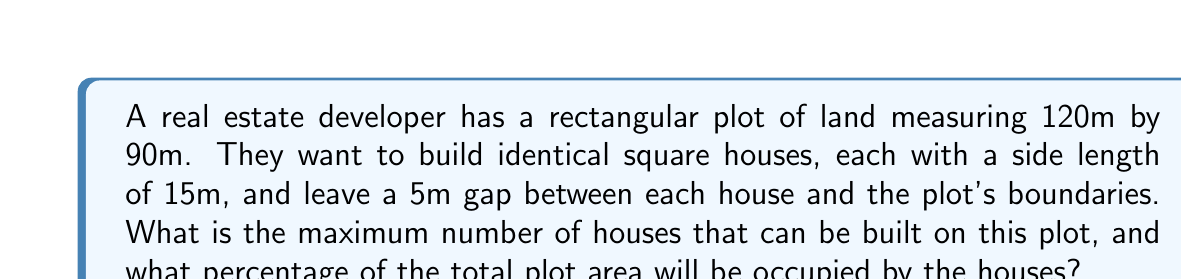Could you help me with this problem? Let's approach this step-by-step:

1) First, calculate the available area for building after accounting for the 5m gap around the edges:
   Available length = $120m - (2 \times 5m) = 110m$
   Available width = $90m - (2 \times 5m) = 80m$

2) Determine how many houses can fit along the length and width:
   Houses along length = $\lfloor \frac{110m}{15m} \rfloor = 7$ houses
   Houses along width = $\lfloor \frac{80m}{15m} \rfloor = 5$ houses

3) Calculate the total number of houses:
   Total houses = $7 \times 5 = 35$ houses

4) Calculate the total area of the plot:
   Total area = $120m \times 90m = 10,800m^2$

5) Calculate the total area occupied by houses:
   Area per house = $15m \times 15m = 225m^2$
   Total house area = $35 \times 225m^2 = 7,875m^2$

6) Calculate the percentage of the plot occupied by houses:
   Percentage = $\frac{7,875m^2}{10,800m^2} \times 100\% \approx 72.92\%$

[asy]
size(200);
draw((0,0)--(120,0)--(120,90)--(0,90)--cycle);
for(int i=0; i<7; ++i)
  for(int j=0; j<5; ++j)
    draw((5+i*15,5+j*15)--(20+i*15,5+j*15)--(20+i*15,20+j*15)--(5+i*15,20+j*15)--cycle);
label("120m", (60,-5), S);
label("90m", (-5,45), W);
[/asy]
Answer: 35 houses; 72.92% occupied 